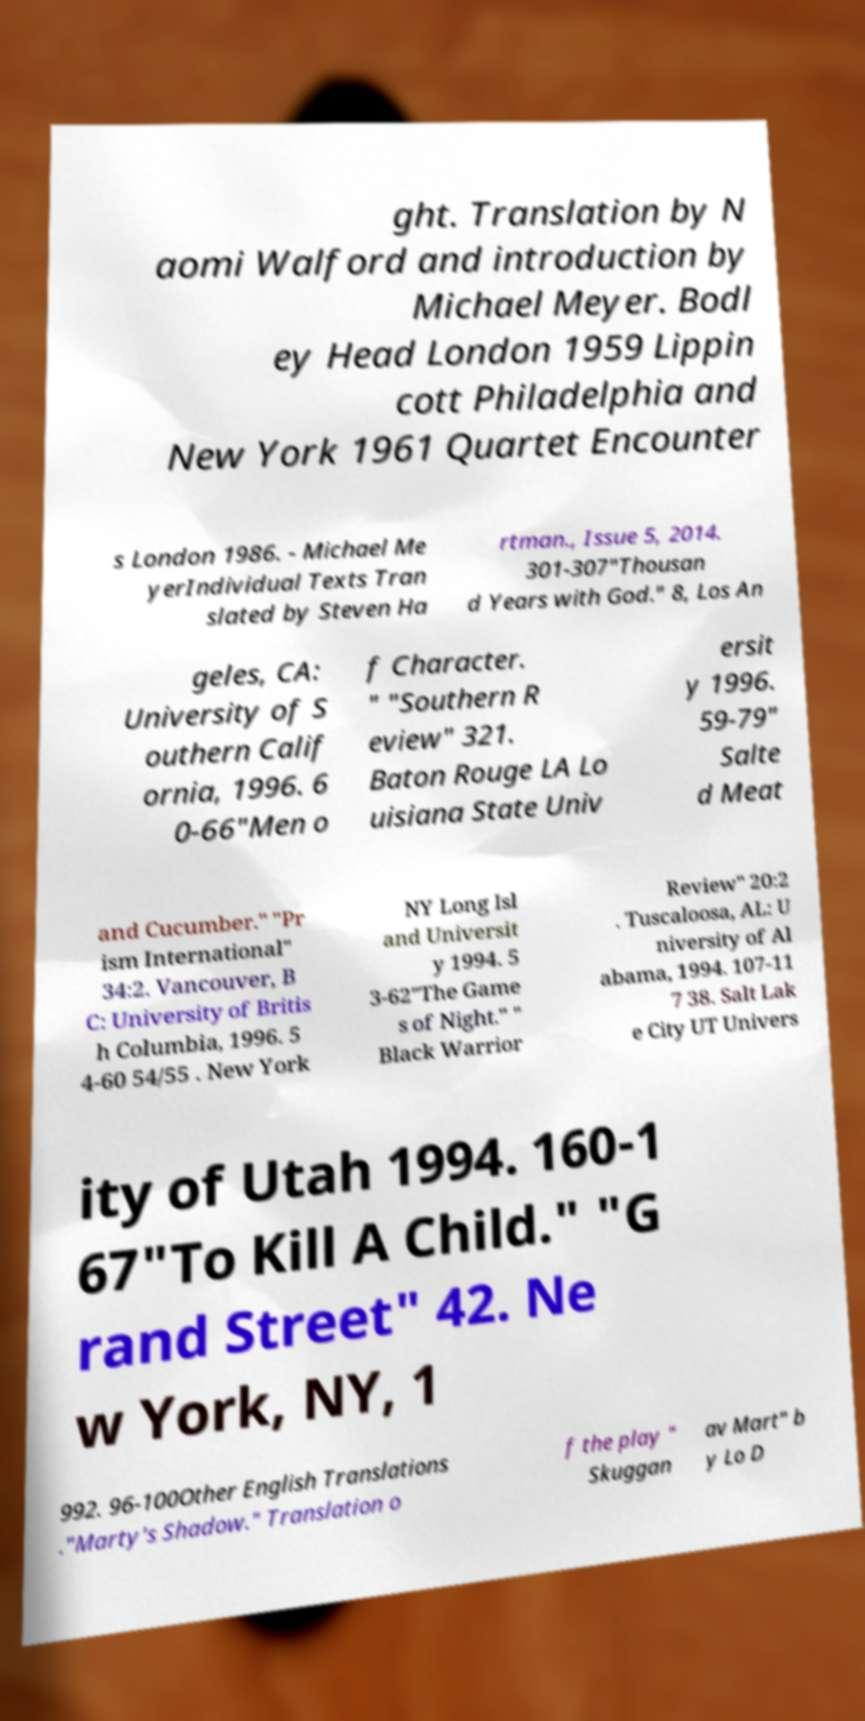Please read and relay the text visible in this image. What does it say? ght. Translation by N aomi Walford and introduction by Michael Meyer. Bodl ey Head London 1959 Lippin cott Philadelphia and New York 1961 Quartet Encounter s London 1986. - Michael Me yerIndividual Texts Tran slated by Steven Ha rtman., Issue 5, 2014. 301-307"Thousan d Years with God." 8, Los An geles, CA: University of S outhern Calif ornia, 1996. 6 0-66"Men o f Character. " "Southern R eview" 321. Baton Rouge LA Lo uisiana State Univ ersit y 1996. 59-79" Salte d Meat and Cucumber." "Pr ism International" 34:2. Vancouver, B C: University of Britis h Columbia, 1996. 5 4-60 54/55 . New York NY Long Isl and Universit y 1994. 5 3-62"The Game s of Night." " Black Warrior Review" 20:2 . Tuscaloosa, AL: U niversity of Al abama, 1994. 107-11 7 38. Salt Lak e City UT Univers ity of Utah 1994. 160-1 67"To Kill A Child." "G rand Street" 42. Ne w York, NY, 1 992. 96-100Other English Translations ."Marty's Shadow." Translation o f the play " Skuggan av Mart" b y Lo D 